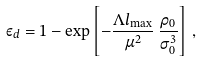Convert formula to latex. <formula><loc_0><loc_0><loc_500><loc_500>\varepsilon _ { d } = 1 - \exp \left [ - \frac { \Lambda l _ { \max } } { \mu ^ { 2 } } \, \frac { \rho _ { 0 } } { \sigma _ { 0 } ^ { 3 } } \right ] \, ,</formula> 